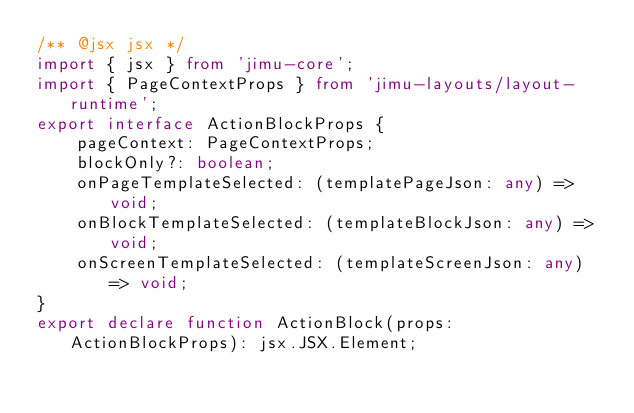Convert code to text. <code><loc_0><loc_0><loc_500><loc_500><_TypeScript_>/** @jsx jsx */
import { jsx } from 'jimu-core';
import { PageContextProps } from 'jimu-layouts/layout-runtime';
export interface ActionBlockProps {
    pageContext: PageContextProps;
    blockOnly?: boolean;
    onPageTemplateSelected: (templatePageJson: any) => void;
    onBlockTemplateSelected: (templateBlockJson: any) => void;
    onScreenTemplateSelected: (templateScreenJson: any) => void;
}
export declare function ActionBlock(props: ActionBlockProps): jsx.JSX.Element;
</code> 